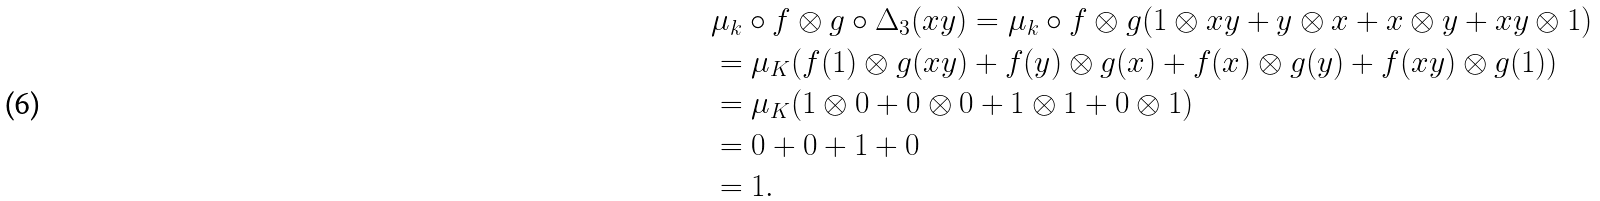<formula> <loc_0><loc_0><loc_500><loc_500>& \mu _ { k } \circ f \otimes g \circ \Delta _ { 3 } ( x y ) = \mu _ { k } \circ f \otimes g ( 1 \otimes x y + y \otimes x + x \otimes y + x y \otimes 1 ) \\ & = \mu _ { K } ( f ( 1 ) \otimes g ( x y ) + f ( y ) \otimes g ( x ) + f ( x ) \otimes g ( y ) + f ( x y ) \otimes g ( 1 ) ) \\ & = \mu _ { K } ( 1 \otimes 0 + 0 \otimes 0 + 1 \otimes 1 + 0 \otimes 1 ) \\ & = 0 + 0 + 1 + 0 \\ & = 1 .</formula> 